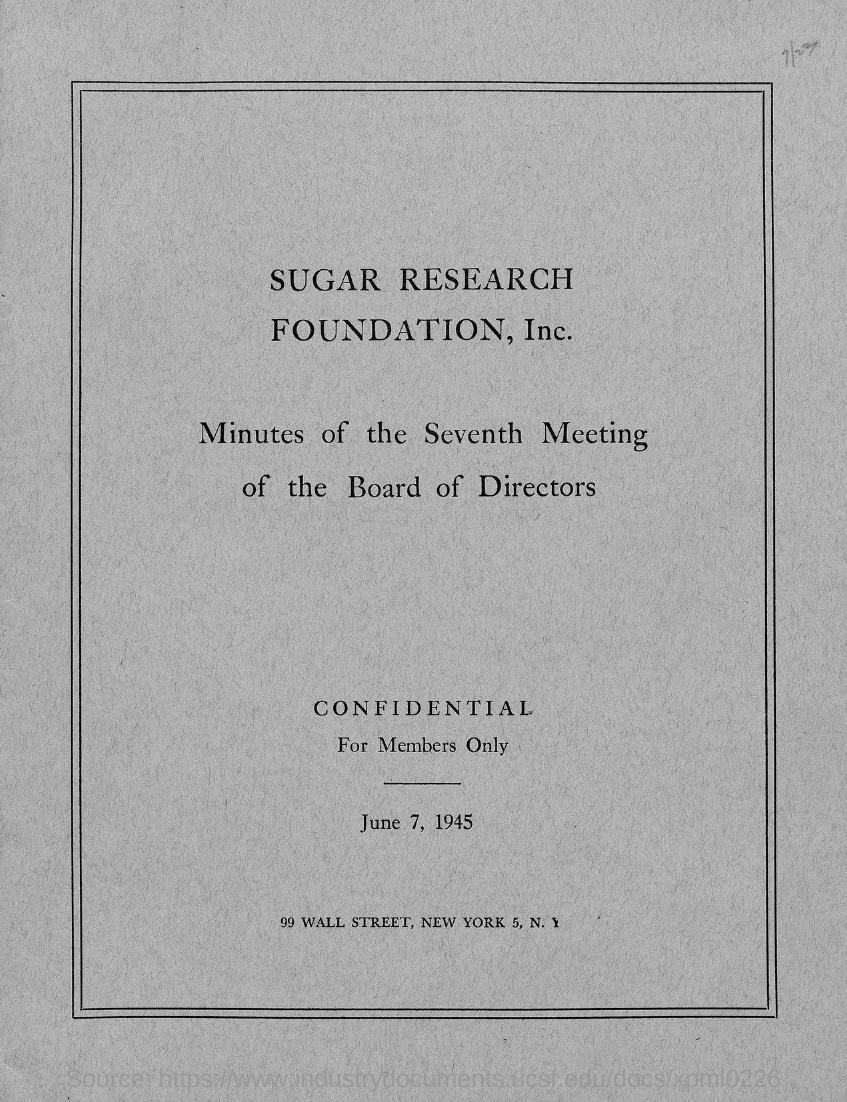What is the name of the foundation mentioned in the given page ?
Provide a short and direct response. Sugar research foundation, inc. What is the month mentioned in the given page ?
Provide a succinct answer. June. What is the year mentioned in the given page ?
Your response must be concise. 1945. What is the name of the street mentioned in the given page?
Provide a succinct answer. Wall street. 